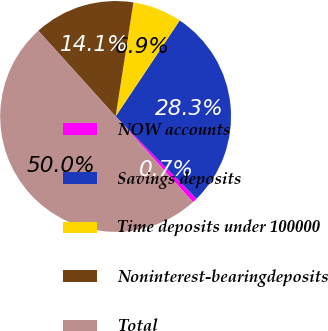Convert chart to OTSL. <chart><loc_0><loc_0><loc_500><loc_500><pie_chart><fcel>NOW accounts<fcel>Savings deposits<fcel>Time deposits under 100000<fcel>Noninterest-bearingdeposits<fcel>Total<nl><fcel>0.68%<fcel>28.27%<fcel>6.9%<fcel>14.15%<fcel>50.0%<nl></chart> 